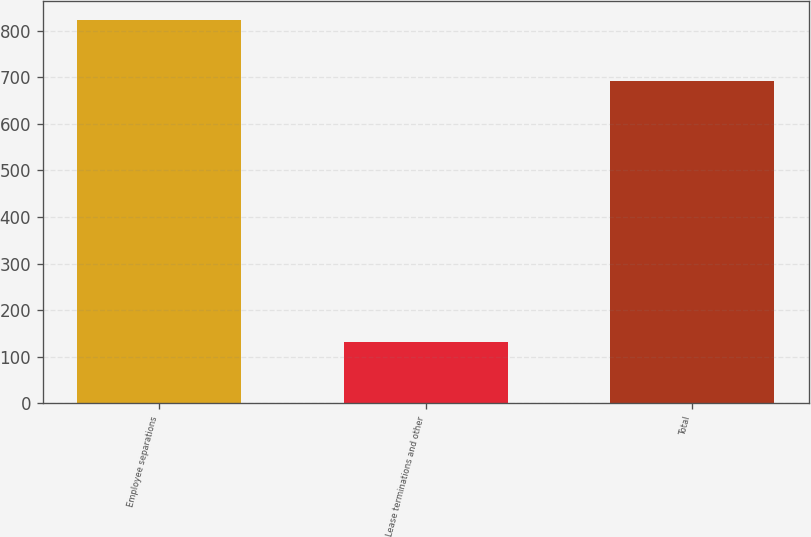Convert chart to OTSL. <chart><loc_0><loc_0><loc_500><loc_500><bar_chart><fcel>Employee separations<fcel>Lease terminations and other<fcel>Total<nl><fcel>823<fcel>131<fcel>692<nl></chart> 